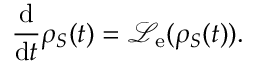Convert formula to latex. <formula><loc_0><loc_0><loc_500><loc_500>\frac { d } { d t } { \rho } _ { S } ( t ) = \mathcal { L } _ { e } ( { \rho } _ { S } ( t ) ) .</formula> 